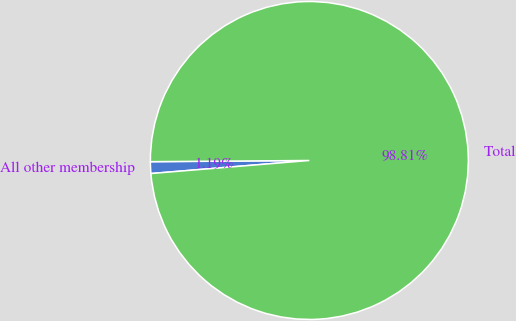Convert chart to OTSL. <chart><loc_0><loc_0><loc_500><loc_500><pie_chart><fcel>All other membership<fcel>Total<nl><fcel>1.19%<fcel>98.81%<nl></chart> 